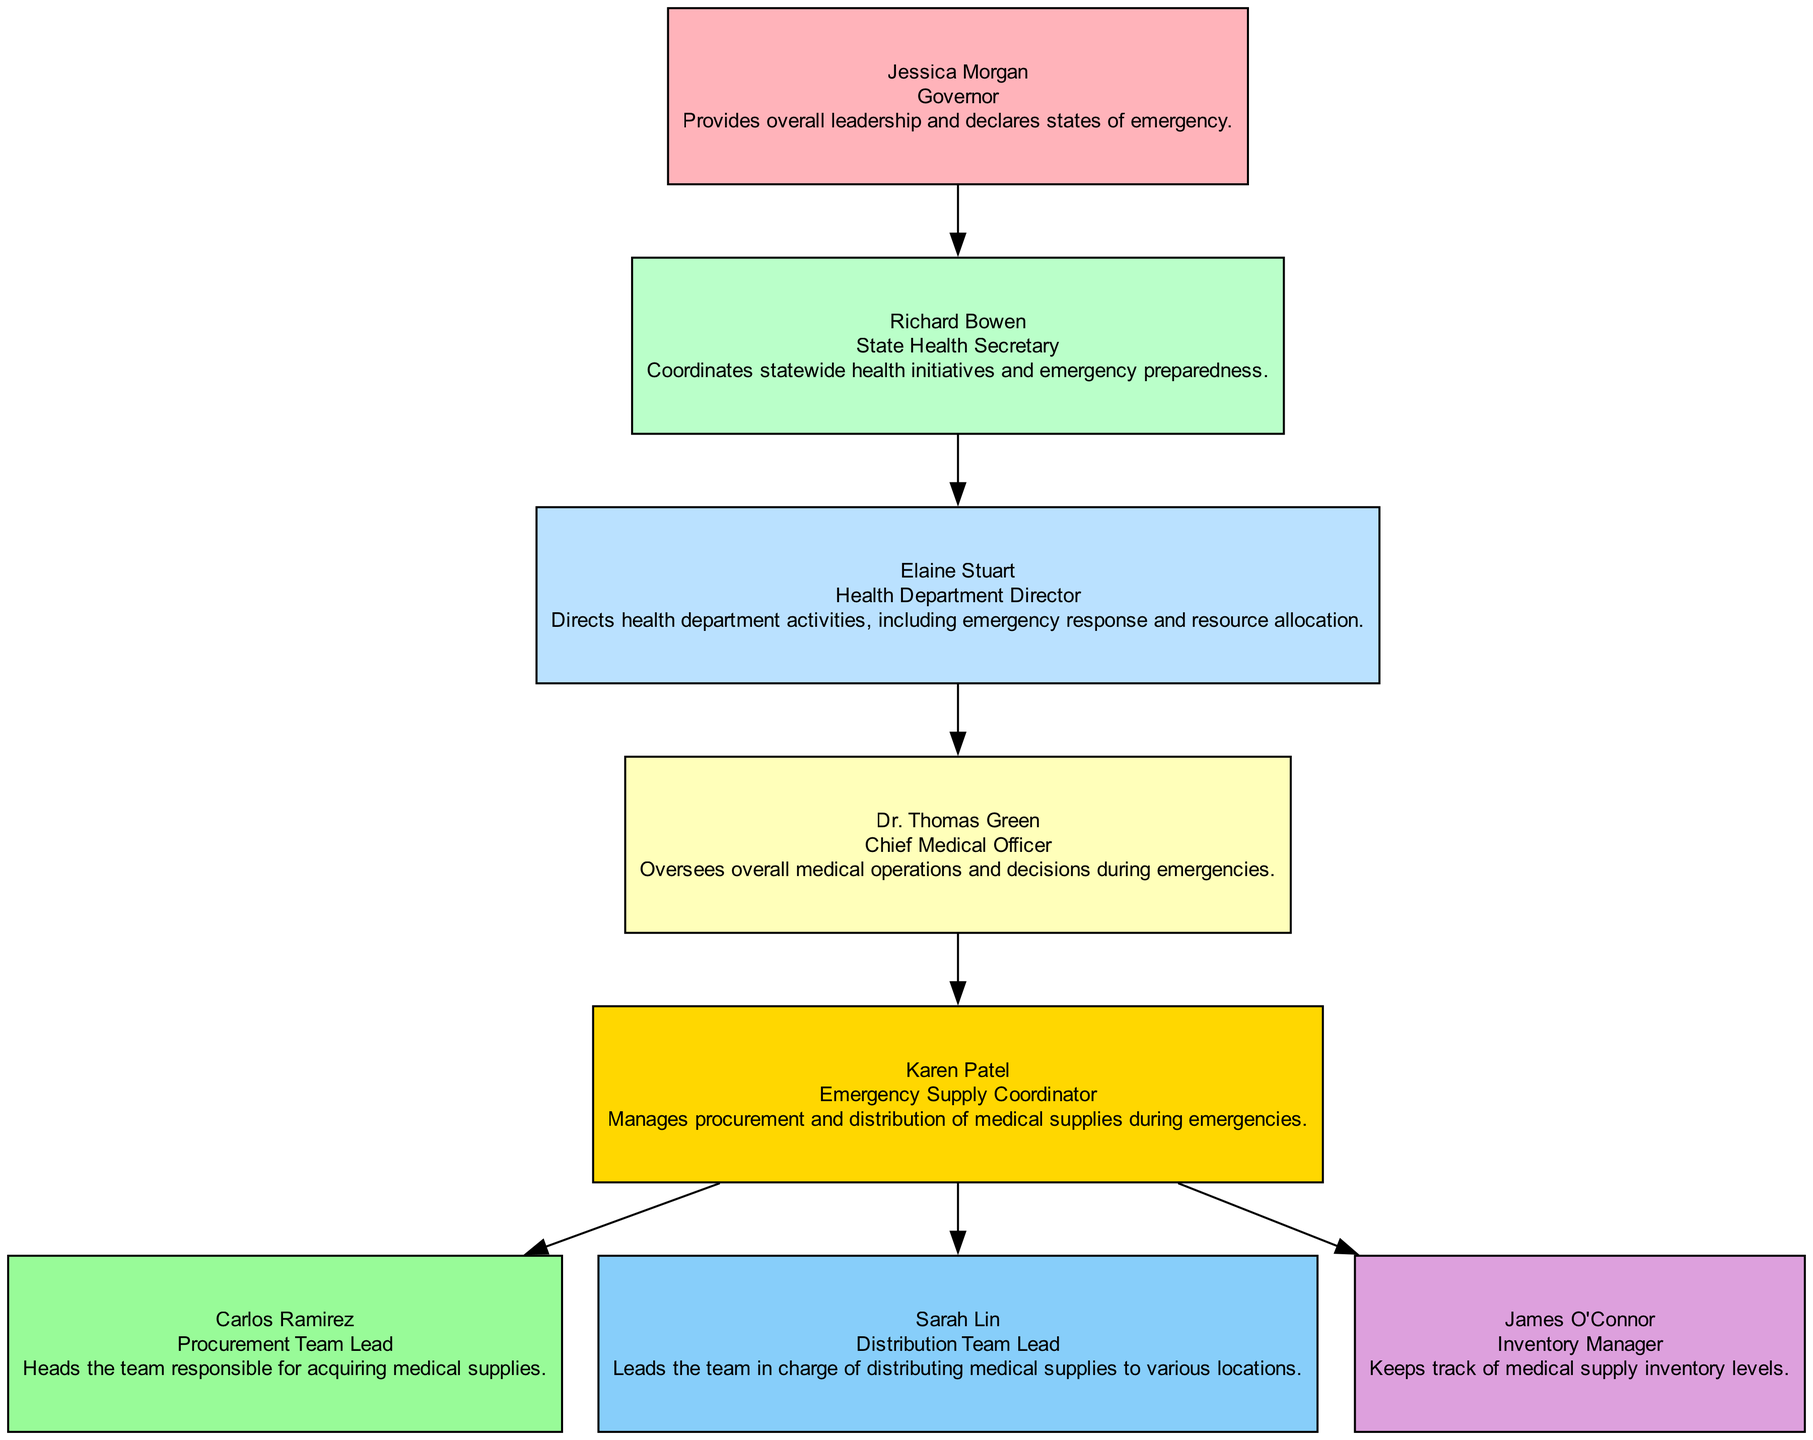What is the role of Dr. Thomas Green? Dr. Thomas Green is the Chief Medical Officer, which means he oversees overall medical operations and decisions during emergencies.
Answer: Chief Medical Officer Who does the Emergency Supply Coordinator report to? The Emergency Supply Coordinator, Karen Patel, reports to the Chief Medical Officer, Dr. Thomas Green, indicating a direct line of responsibility in the commands.
Answer: Chief Medical Officer How many individuals report directly to the Emergency Supply Coordinator? The Emergency Supply Coordinator has three individuals reporting to her, including the Procurement Team Lead, Distribution Team Lead, and Inventory Manager.
Answer: 3 What is the primary responsibility of the Governor? The Governor, Jessica Morgan, has the primary responsibility of providing overall leadership and declaring states of emergency, which is crucial during medical emergencies.
Answer: Provides overall leadership Who is responsible for keeping track of medical supply inventory levels? The person responsible for keeping track of medical supply inventory levels is James O'Connor, who holds the position of Inventory Manager within the emergency supply management chain.
Answer: James O'Connor What is the relationship between the Health Department Director and the State Health Secretary? The Health Department Director, Elaine Stuart, reports to the State Health Secretary, Richard Bowen, indicating that she is subordinate to him in the hierarchy of command.
Answer: Reports to Which position is at the top of the chain of command? At the top of the chain of command is the Governor, Jessica Morgan, who oversees the entire structure of emergency medical supply management and is responsible for state decision-making.
Answer: Governor If a new emergency arises, who makes the first immediate operational decision? The first immediate operational decision in a new emergency would be made by the Chief Medical Officer, Dr. Thomas Green, as he directly oversees medical operations during such situations.
Answer: Dr. Thomas Green Which team lead is responsible for the distribution of medical supplies? Sarah Lin holds the position of Distribution Team Lead and is explicitly responsible for leading the team that distributes medical supplies to various locations during emergencies.
Answer: Sarah Lin 